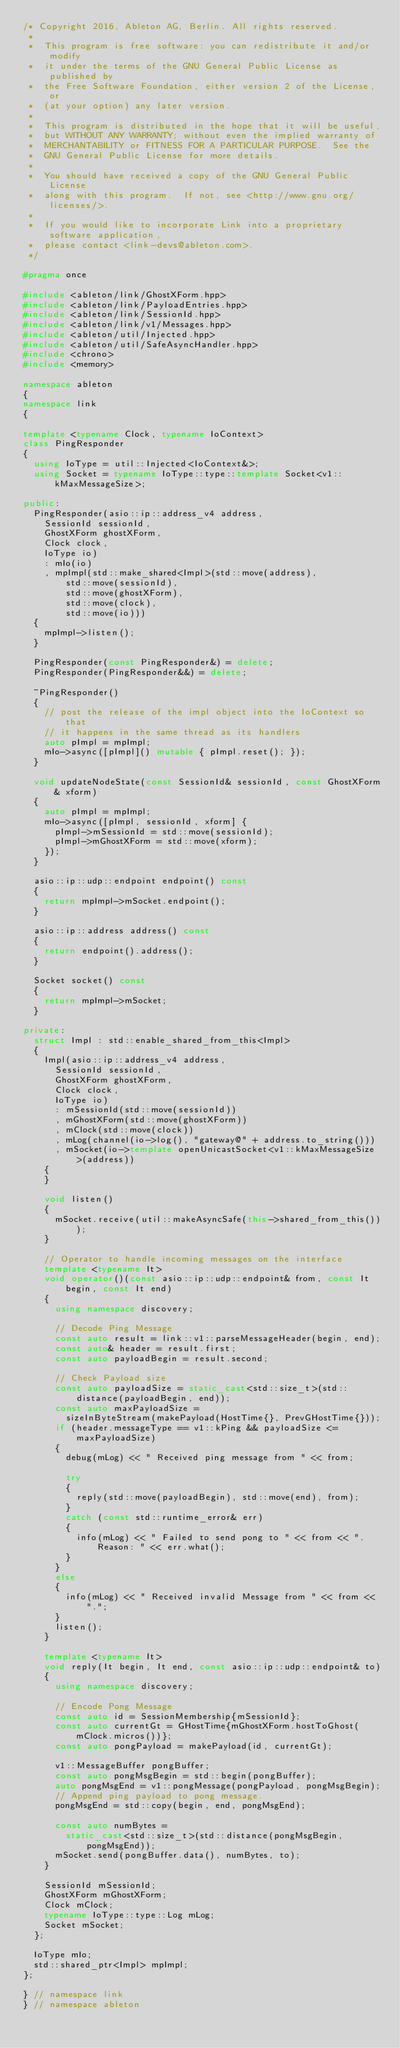Convert code to text. <code><loc_0><loc_0><loc_500><loc_500><_C++_>/* Copyright 2016, Ableton AG, Berlin. All rights reserved.
 *
 *  This program is free software: you can redistribute it and/or modify
 *  it under the terms of the GNU General Public License as published by
 *  the Free Software Foundation, either version 2 of the License, or
 *  (at your option) any later version.
 *
 *  This program is distributed in the hope that it will be useful,
 *  but WITHOUT ANY WARRANTY; without even the implied warranty of
 *  MERCHANTABILITY or FITNESS FOR A PARTICULAR PURPOSE.  See the
 *  GNU General Public License for more details.
 *
 *  You should have received a copy of the GNU General Public License
 *  along with this program.  If not, see <http://www.gnu.org/licenses/>.
 *
 *  If you would like to incorporate Link into a proprietary software application,
 *  please contact <link-devs@ableton.com>.
 */

#pragma once

#include <ableton/link/GhostXForm.hpp>
#include <ableton/link/PayloadEntries.hpp>
#include <ableton/link/SessionId.hpp>
#include <ableton/link/v1/Messages.hpp>
#include <ableton/util/Injected.hpp>
#include <ableton/util/SafeAsyncHandler.hpp>
#include <chrono>
#include <memory>

namespace ableton
{
namespace link
{

template <typename Clock, typename IoContext>
class PingResponder
{
  using IoType = util::Injected<IoContext&>;
  using Socket = typename IoType::type::template Socket<v1::kMaxMessageSize>;

public:
  PingResponder(asio::ip::address_v4 address,
    SessionId sessionId,
    GhostXForm ghostXForm,
    Clock clock,
    IoType io)
    : mIo(io)
    , mpImpl(std::make_shared<Impl>(std::move(address),
        std::move(sessionId),
        std::move(ghostXForm),
        std::move(clock),
        std::move(io)))
  {
    mpImpl->listen();
  }

  PingResponder(const PingResponder&) = delete;
  PingResponder(PingResponder&&) = delete;

  ~PingResponder()
  {
    // post the release of the impl object into the IoContext so that
    // it happens in the same thread as its handlers
    auto pImpl = mpImpl;
    mIo->async([pImpl]() mutable { pImpl.reset(); });
  }

  void updateNodeState(const SessionId& sessionId, const GhostXForm& xform)
  {
    auto pImpl = mpImpl;
    mIo->async([pImpl, sessionId, xform] {
      pImpl->mSessionId = std::move(sessionId);
      pImpl->mGhostXForm = std::move(xform);
    });
  }

  asio::ip::udp::endpoint endpoint() const
  {
    return mpImpl->mSocket.endpoint();
  }

  asio::ip::address address() const
  {
    return endpoint().address();
  }

  Socket socket() const
  {
    return mpImpl->mSocket;
  }

private:
  struct Impl : std::enable_shared_from_this<Impl>
  {
    Impl(asio::ip::address_v4 address,
      SessionId sessionId,
      GhostXForm ghostXForm,
      Clock clock,
      IoType io)
      : mSessionId(std::move(sessionId))
      , mGhostXForm(std::move(ghostXForm))
      , mClock(std::move(clock))
      , mLog(channel(io->log(), "gateway@" + address.to_string()))
      , mSocket(io->template openUnicastSocket<v1::kMaxMessageSize>(address))
    {
    }

    void listen()
    {
      mSocket.receive(util::makeAsyncSafe(this->shared_from_this()));
    }

    // Operator to handle incoming messages on the interface
    template <typename It>
    void operator()(const asio::ip::udp::endpoint& from, const It begin, const It end)
    {
      using namespace discovery;

      // Decode Ping Message
      const auto result = link::v1::parseMessageHeader(begin, end);
      const auto& header = result.first;
      const auto payloadBegin = result.second;

      // Check Payload size
      const auto payloadSize = static_cast<std::size_t>(std::distance(payloadBegin, end));
      const auto maxPayloadSize =
        sizeInByteStream(makePayload(HostTime{}, PrevGHostTime{}));
      if (header.messageType == v1::kPing && payloadSize <= maxPayloadSize)
      {
        debug(mLog) << " Received ping message from " << from;

        try
        {
          reply(std::move(payloadBegin), std::move(end), from);
        }
        catch (const std::runtime_error& err)
        {
          info(mLog) << " Failed to send pong to " << from << ". Reason: " << err.what();
        }
      }
      else
      {
        info(mLog) << " Received invalid Message from " << from << ".";
      }
      listen();
    }

    template <typename It>
    void reply(It begin, It end, const asio::ip::udp::endpoint& to)
    {
      using namespace discovery;

      // Encode Pong Message
      const auto id = SessionMembership{mSessionId};
      const auto currentGt = GHostTime{mGhostXForm.hostToGhost(mClock.micros())};
      const auto pongPayload = makePayload(id, currentGt);

      v1::MessageBuffer pongBuffer;
      const auto pongMsgBegin = std::begin(pongBuffer);
      auto pongMsgEnd = v1::pongMessage(pongPayload, pongMsgBegin);
      // Append ping payload to pong message.
      pongMsgEnd = std::copy(begin, end, pongMsgEnd);

      const auto numBytes =
        static_cast<std::size_t>(std::distance(pongMsgBegin, pongMsgEnd));
      mSocket.send(pongBuffer.data(), numBytes, to);
    }

    SessionId mSessionId;
    GhostXForm mGhostXForm;
    Clock mClock;
    typename IoType::type::Log mLog;
    Socket mSocket;
  };

  IoType mIo;
  std::shared_ptr<Impl> mpImpl;
};

} // namespace link
} // namespace ableton
</code> 